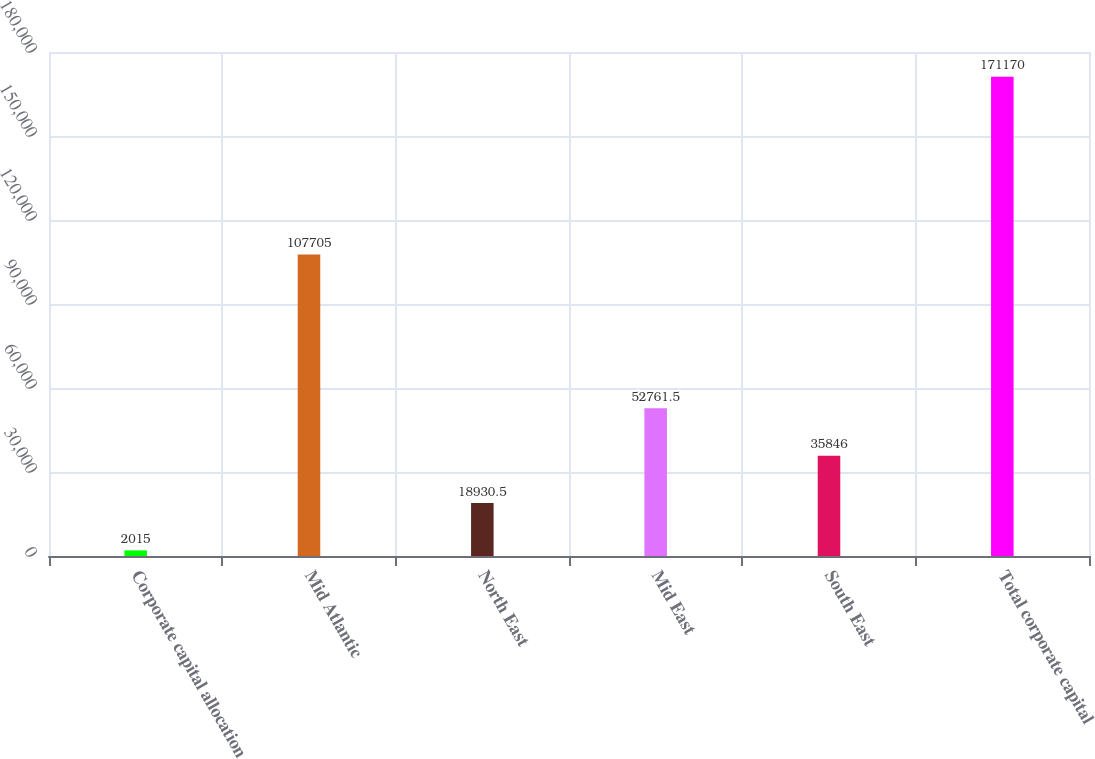<chart> <loc_0><loc_0><loc_500><loc_500><bar_chart><fcel>Corporate capital allocation<fcel>Mid Atlantic<fcel>North East<fcel>Mid East<fcel>South East<fcel>Total corporate capital<nl><fcel>2015<fcel>107705<fcel>18930.5<fcel>52761.5<fcel>35846<fcel>171170<nl></chart> 